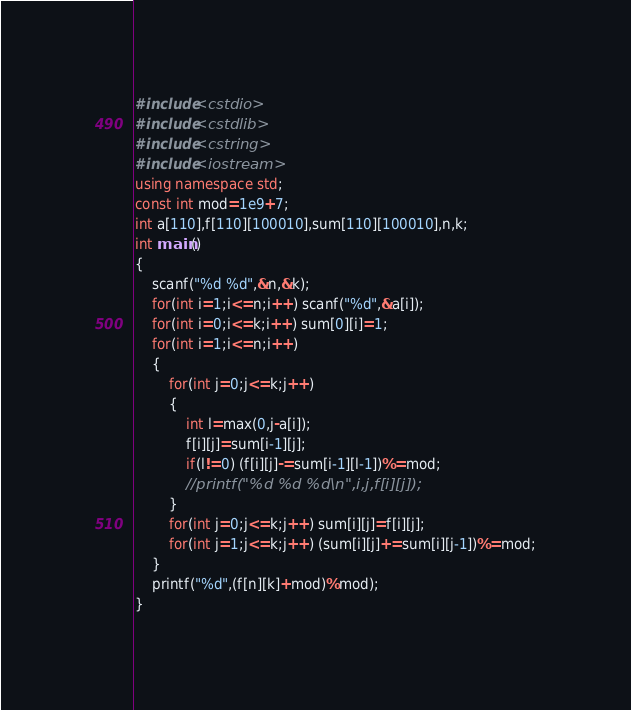Convert code to text. <code><loc_0><loc_0><loc_500><loc_500><_C++_>#include<cstdio>
#include<cstdlib>
#include<cstring>
#include<iostream>
using namespace std;
const int mod=1e9+7;
int a[110],f[110][100010],sum[110][100010],n,k;
int main()
{
	scanf("%d %d",&n,&k);
	for(int i=1;i<=n;i++) scanf("%d",&a[i]);
	for(int i=0;i<=k;i++) sum[0][i]=1;
	for(int i=1;i<=n;i++)
	{
		for(int j=0;j<=k;j++)
		{
			int l=max(0,j-a[i]);
			f[i][j]=sum[i-1][j];
			if(l!=0) (f[i][j]-=sum[i-1][l-1])%=mod;
			//printf("%d %d %d\n",i,j,f[i][j]);
		}
		for(int j=0;j<=k;j++) sum[i][j]=f[i][j];
		for(int j=1;j<=k;j++) (sum[i][j]+=sum[i][j-1])%=mod;
	}
	printf("%d",(f[n][k]+mod)%mod);
}</code> 